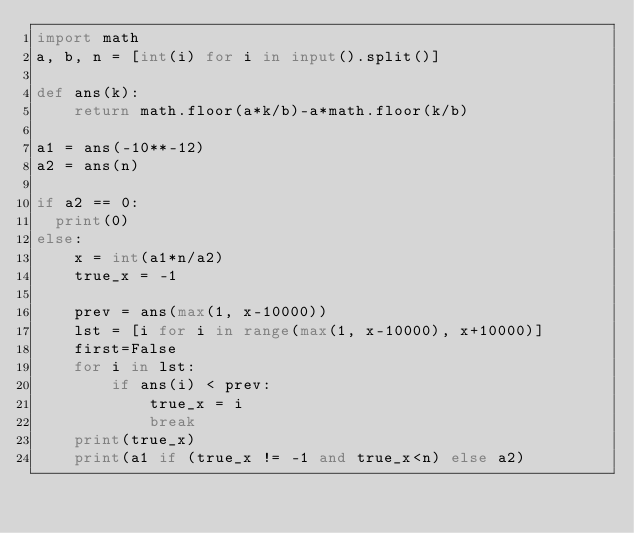Convert code to text. <code><loc_0><loc_0><loc_500><loc_500><_Python_>import math
a, b, n = [int(i) for i in input().split()]

def ans(k):
    return math.floor(a*k/b)-a*math.floor(k/b)

a1 = ans(-10**-12)
a2 = ans(n)

if a2 == 0:
  print(0)
else:
    x = int(a1*n/a2)
    true_x = -1

    prev = ans(max(1, x-10000))
    lst = [i for i in range(max(1, x-10000), x+10000)]
    first=False
    for i in lst:
        if ans(i) < prev:
            true_x = i
            break
    print(true_x)
    print(a1 if (true_x != -1 and true_x<n) else a2)</code> 